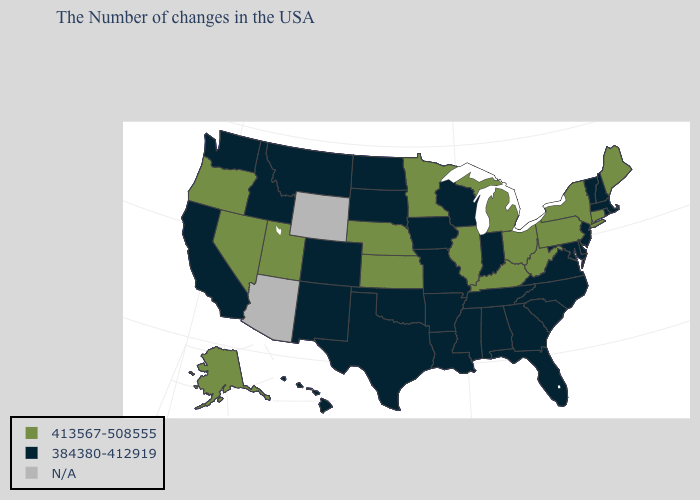What is the value of West Virginia?
Give a very brief answer. 413567-508555. Does the first symbol in the legend represent the smallest category?
Keep it brief. No. What is the value of Colorado?
Write a very short answer. 384380-412919. Among the states that border New York , does Massachusetts have the highest value?
Be succinct. No. Among the states that border Virginia , does Kentucky have the lowest value?
Concise answer only. No. Which states have the lowest value in the USA?
Give a very brief answer. Massachusetts, Rhode Island, New Hampshire, Vermont, New Jersey, Delaware, Maryland, Virginia, North Carolina, South Carolina, Florida, Georgia, Indiana, Alabama, Tennessee, Wisconsin, Mississippi, Louisiana, Missouri, Arkansas, Iowa, Oklahoma, Texas, South Dakota, North Dakota, Colorado, New Mexico, Montana, Idaho, California, Washington, Hawaii. Among the states that border Iowa , does Wisconsin have the lowest value?
Be succinct. Yes. What is the highest value in states that border North Dakota?
Answer briefly. 413567-508555. Name the states that have a value in the range 413567-508555?
Keep it brief. Maine, Connecticut, New York, Pennsylvania, West Virginia, Ohio, Michigan, Kentucky, Illinois, Minnesota, Kansas, Nebraska, Utah, Nevada, Oregon, Alaska. What is the value of Alaska?
Write a very short answer. 413567-508555. Name the states that have a value in the range N/A?
Write a very short answer. Wyoming, Arizona. Among the states that border Iowa , which have the lowest value?
Keep it brief. Wisconsin, Missouri, South Dakota. What is the highest value in the USA?
Answer briefly. 413567-508555. 